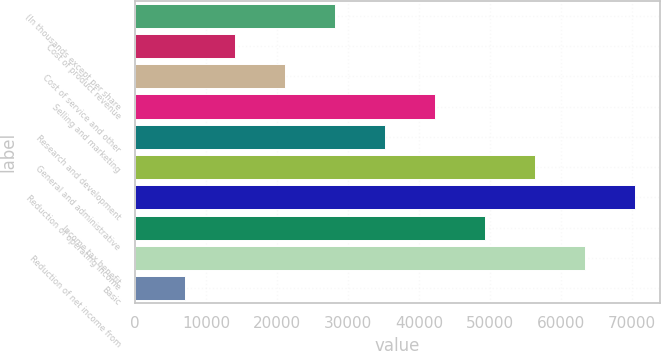Convert chart to OTSL. <chart><loc_0><loc_0><loc_500><loc_500><bar_chart><fcel>(In thousands except per share<fcel>Cost of product revenue<fcel>Cost of service and other<fcel>Selling and marketing<fcel>Research and development<fcel>General and administrative<fcel>Reduction of operating income<fcel>Income tax benefit<fcel>Reduction of net income from<fcel>Basic<nl><fcel>28136.1<fcel>14068.1<fcel>21102.1<fcel>42204.1<fcel>35170.1<fcel>56272<fcel>70340<fcel>49238.1<fcel>63306<fcel>7034.11<nl></chart> 